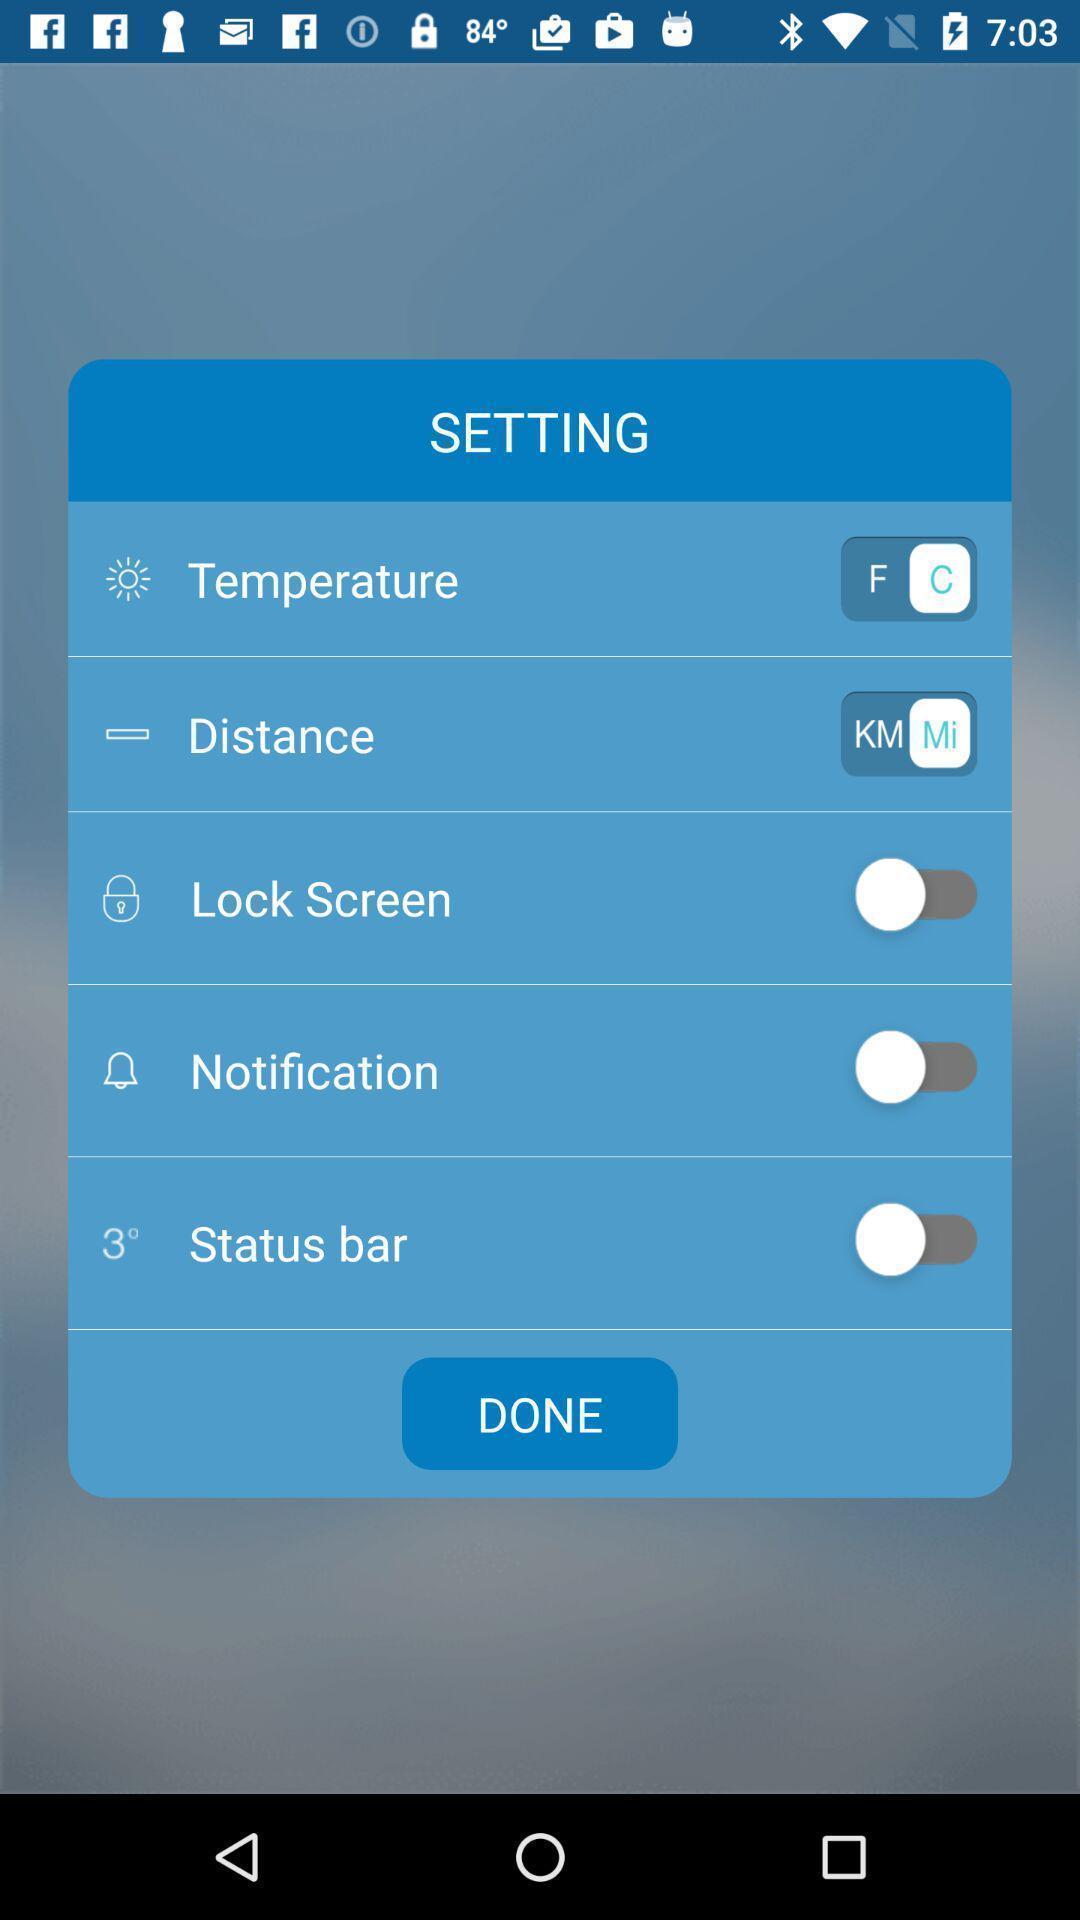Give me a narrative description of this picture. Pop up showing different setting options on an app. 